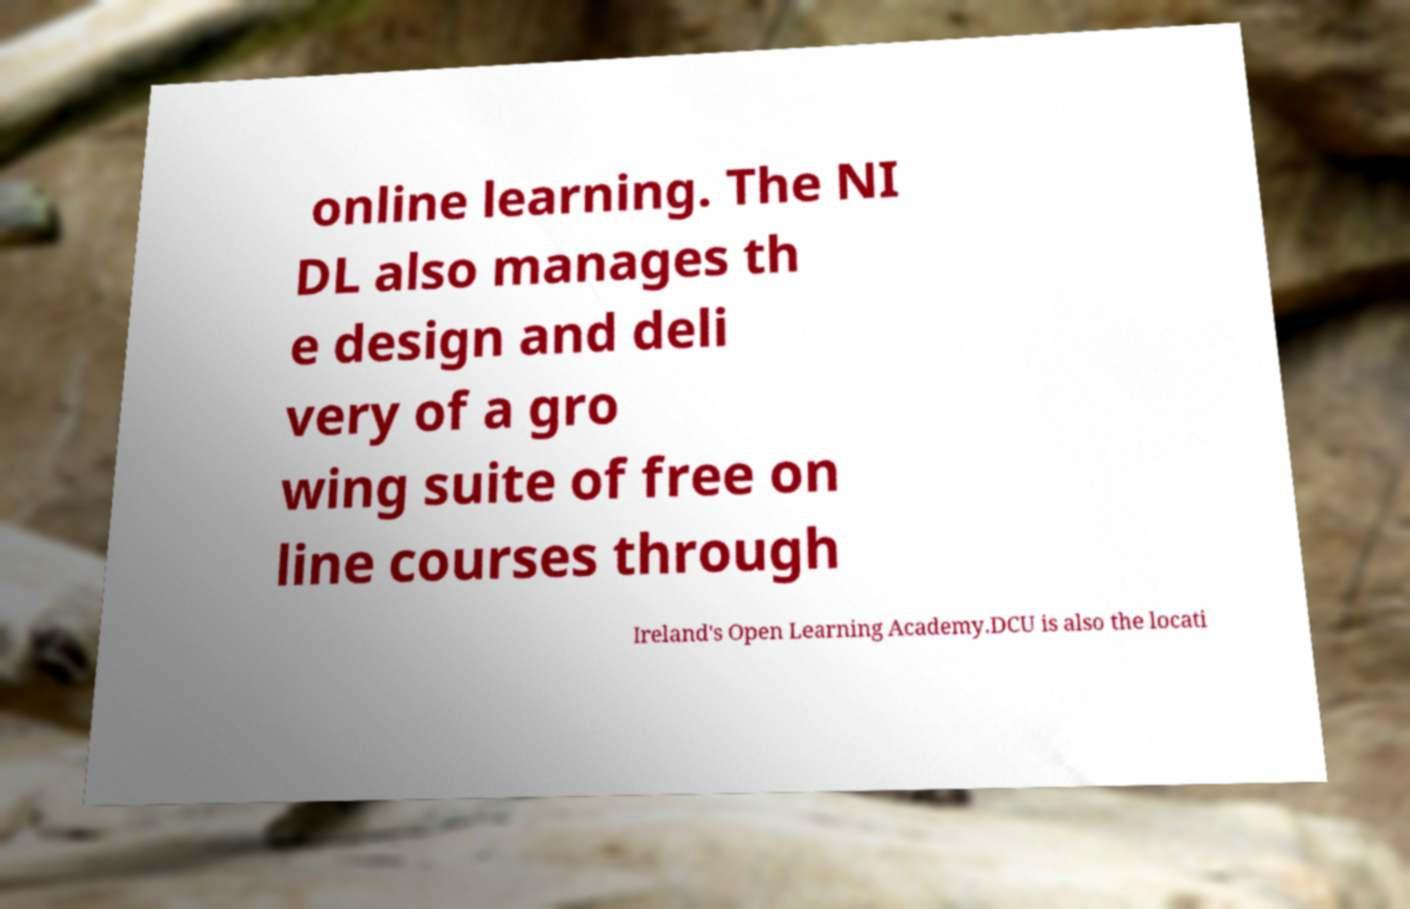What messages or text are displayed in this image? I need them in a readable, typed format. online learning. The NI DL also manages th e design and deli very of a gro wing suite of free on line courses through Ireland's Open Learning Academy.DCU is also the locati 